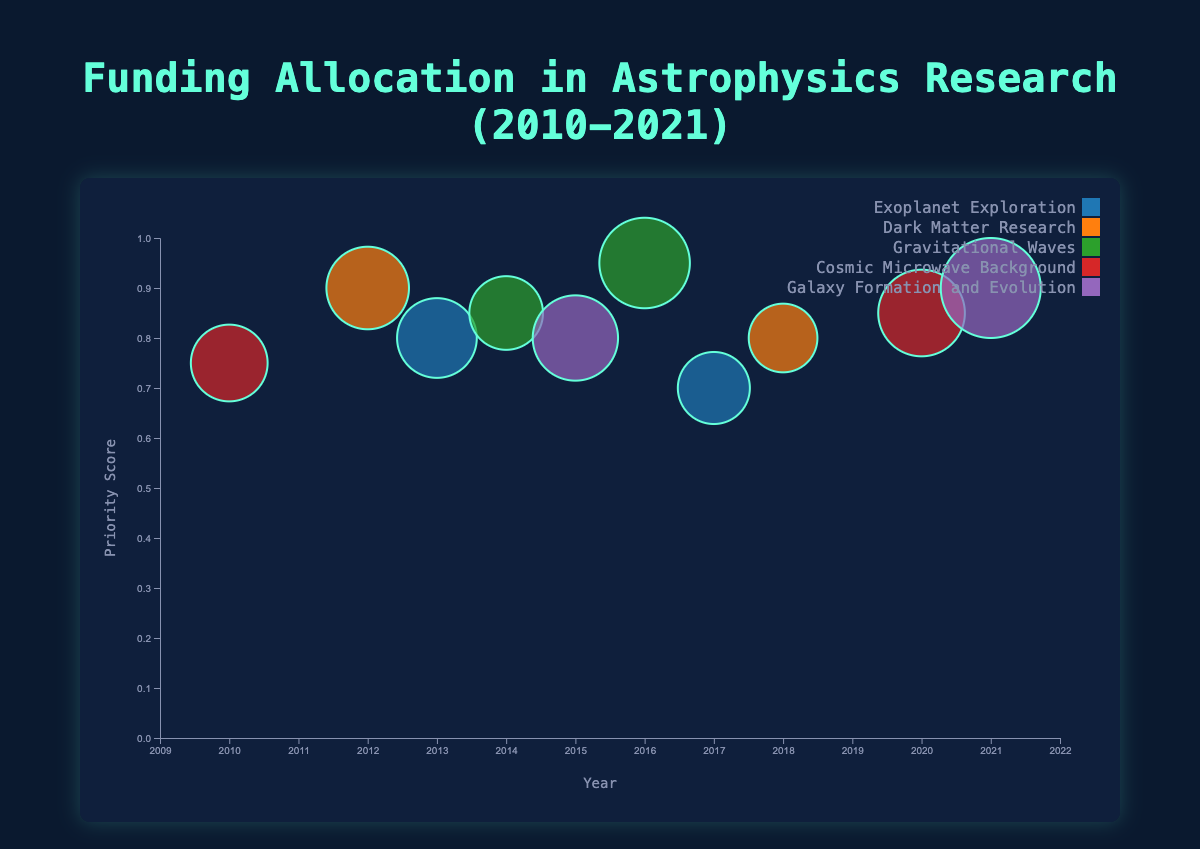What is the title of the chart? The chart's title is found at the top and reads "Funding Allocation in Astrophysics Research (2010-2021)"
Answer: Funding Allocation in Astrophysics Research (2010-2021) Which research area received the highest funding in any year? By inspecting the bubble sizes, we see that "James Webb Space Telescope" for "Galaxy Formation and Evolution" in 2021 has the largest bubble, indicating the highest funding of $200M.
Answer: Galaxy Formation and Evolution in 2021 How many research areas are represented in the chart? The legend shows the unique research areas. Counting these gives us five: Exoplanet Exploration, Dark Matter Research, Gravitational Waves, Cosmic Microwave Background, and Galaxy Formation and Evolution.
Answer: 5 What is the research area with the highest priority score? The "Gravitational Waves" research area by "LIGO Scientific Collaboration" in 2016 has the highest priority score of 0.95, as indicated by its vertical position on the y-axis.
Answer: Gravitational Waves How did the funding allocation for "Cosmic Microwave Background" change from 2010 to 2020? In 2010, "Planck Collaboration" received $110M, and in 2020, "South Pole Telescope" received $145M. The funding increased by $35M.
Answer: Increased by $35M Compare the funding amount of "Exoplanet Exploration" projects in 2013 and 2017. The funding for "NASA" in 2013 was $120M and for "European Space Agency" in 2017 was $95M. The difference is $120M - $95M = $25M.
Answer: $25M more in 2013 Which project had the highest priority score with the lowest funding amount? The lowest funding amount with a high priority score can be identified by comparing the priority scores and bubble sizes. "Kavli Institute for Particle Astrophysics and Cosmology" for "Dark Matter Research" in 2018 had $85M funding with a 0.8 priority score.
Answer: Kavli Institute for Particle Astrophysics and Cosmology What is the average funding amount for "Dark Matter Research" projects? The funding amounts are $130M in 2012 and $85M in 2018. The average is (130 + 85) / 2 = 215 / 2 = $107.5M.
Answer: $107.5M Which year had the widest range of funding amounts across all projects? Examine the horizontal spread (year) for variations in bubble sizes (funding). 2015 spreads from "Hubble Space Telescope" with $140M to other projects showing wider funding variations.
Answer: 2015 What was the total funding amount allocated to "Gravitational Waves" across all years? The funding amounts are $160M in 2016 (LIGO) and $100M in 2014 (VIRGO). The total is 160 + 100 = $260M.
Answer: $260M 